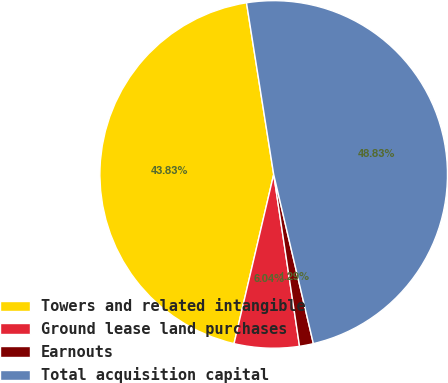Convert chart. <chart><loc_0><loc_0><loc_500><loc_500><pie_chart><fcel>Towers and related intangible<fcel>Ground lease land purchases<fcel>Earnouts<fcel>Total acquisition capital<nl><fcel>43.83%<fcel>6.04%<fcel>1.29%<fcel>48.83%<nl></chart> 